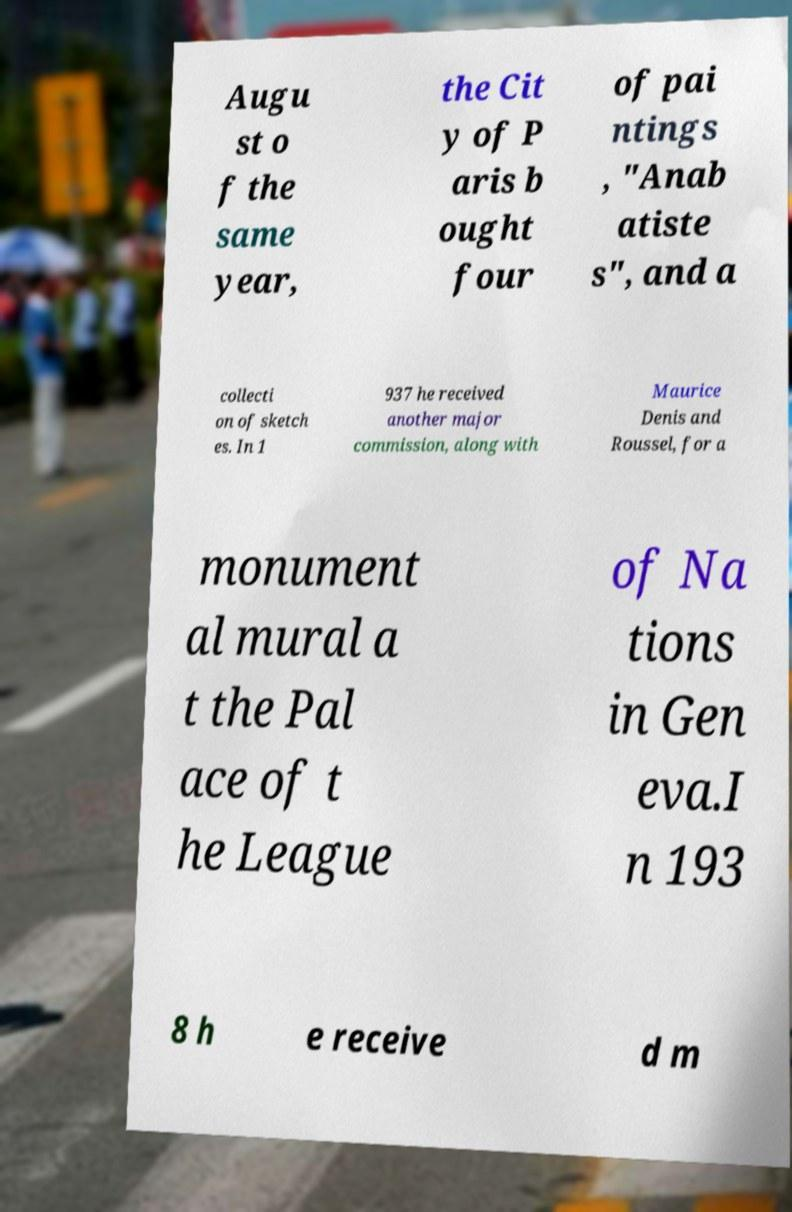Please identify and transcribe the text found in this image. Augu st o f the same year, the Cit y of P aris b ought four of pai ntings , "Anab atiste s", and a collecti on of sketch es. In 1 937 he received another major commission, along with Maurice Denis and Roussel, for a monument al mural a t the Pal ace of t he League of Na tions in Gen eva.I n 193 8 h e receive d m 